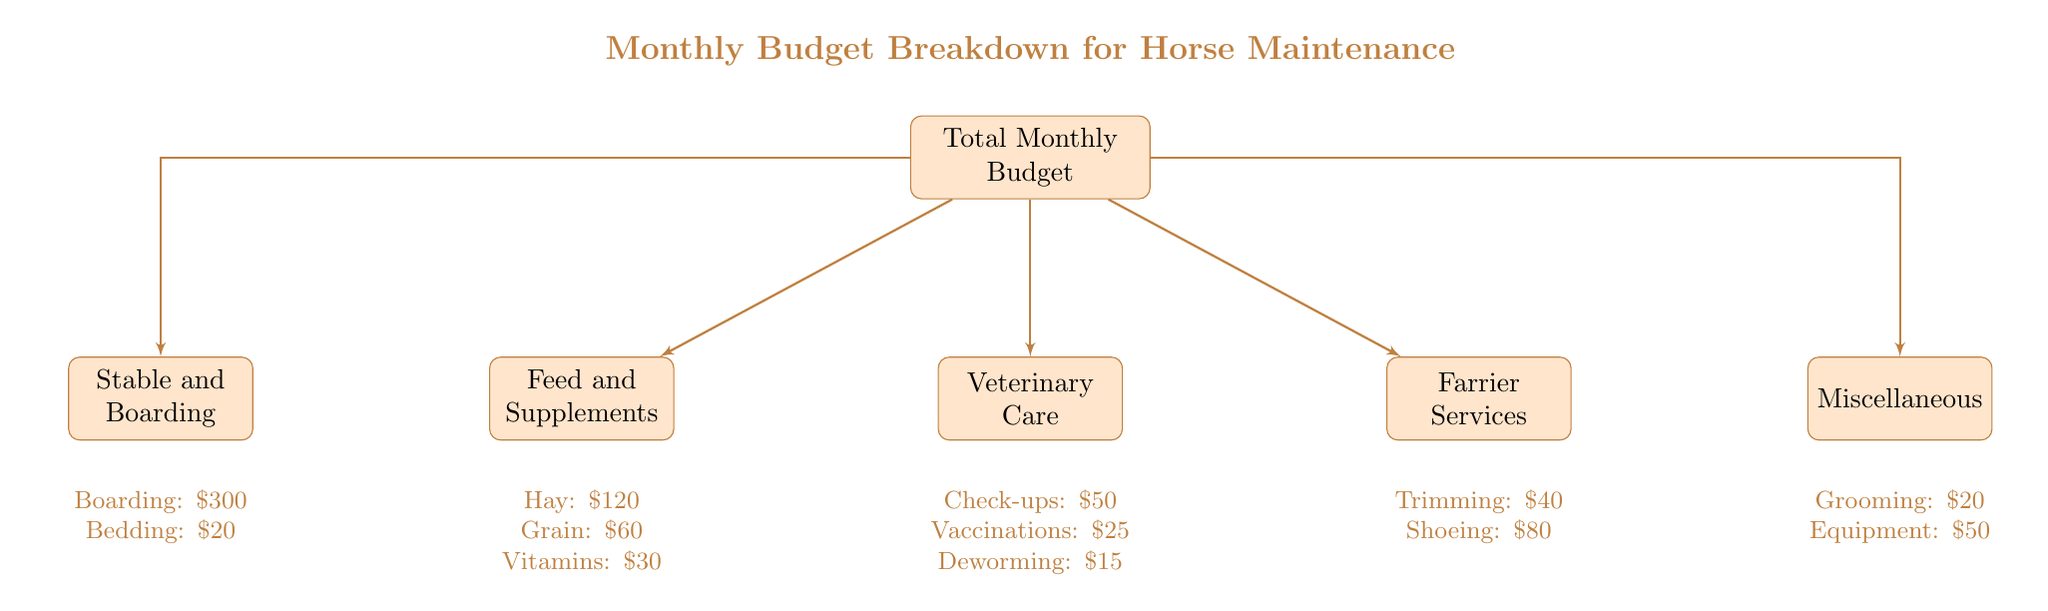What is the total cost of Feed and Supplements? To find the total cost of Feed and Supplements, we need to add the individual costs: Hay ($120) + Grain ($60) + Vitamins ($30). The sum is $120 + $60 + $30 = $210.
Answer: $210 What service includes a cost of $80? Looking at the Farrier Services section of the diagram, the only service listed with a cost of $80 is "Shoeing (if needed)".
Answer: Shoeing (if needed) How many main categories are there in the diagram? The diagram contains five main categories branching from the Total Monthly Budget: Feed and Supplements, Veterinary Care, Farrier Services, Stable and Boarding, and Miscellaneous. This totals to five categories.
Answer: 5 What is the combined cost of Veterinary Care services? To determine the combined cost of Veterinary Care services, we add the costs: Routine Check-ups ($50) + Vaccinations ($25) + Deworming ($15). The total is $50 + $25 + $15 = $90.
Answer: $90 What specific item costs $20 in the Miscellaneous category? In the Miscellaneous category, the item listed with a cost of $20 is "Grooming Supplies".
Answer: Grooming Supplies Which category has the highest total cost? By reviewing the total costs of each category, Stable and Boarding has a total of $320 ($300 boarding + $20 bedding), which is higher than the others.
Answer: Stable and Boarding What is the total monthly budget for all horse maintenance categories? To compute the total monthly budget, we sum up all the amounts from each category: Feed ($210) + Veterinary Care ($90) + Farrier ($120) + Stable and Boarding ($320) + Miscellaneous ($70). The total is $210 + $90 + $120 + $320 + $70 = $810.
Answer: $810 What type of services are detailed in the Farrier Services section? The Farrier Services section details two types of services: "Trimming" which costs $40 and "Shoeing (if needed)" which costs $80.
Answer: Trimming and Shoeing (if needed) 